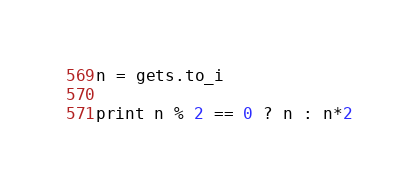Convert code to text. <code><loc_0><loc_0><loc_500><loc_500><_Ruby_>n = gets.to_i

print n % 2 == 0 ? n : n*2
</code> 